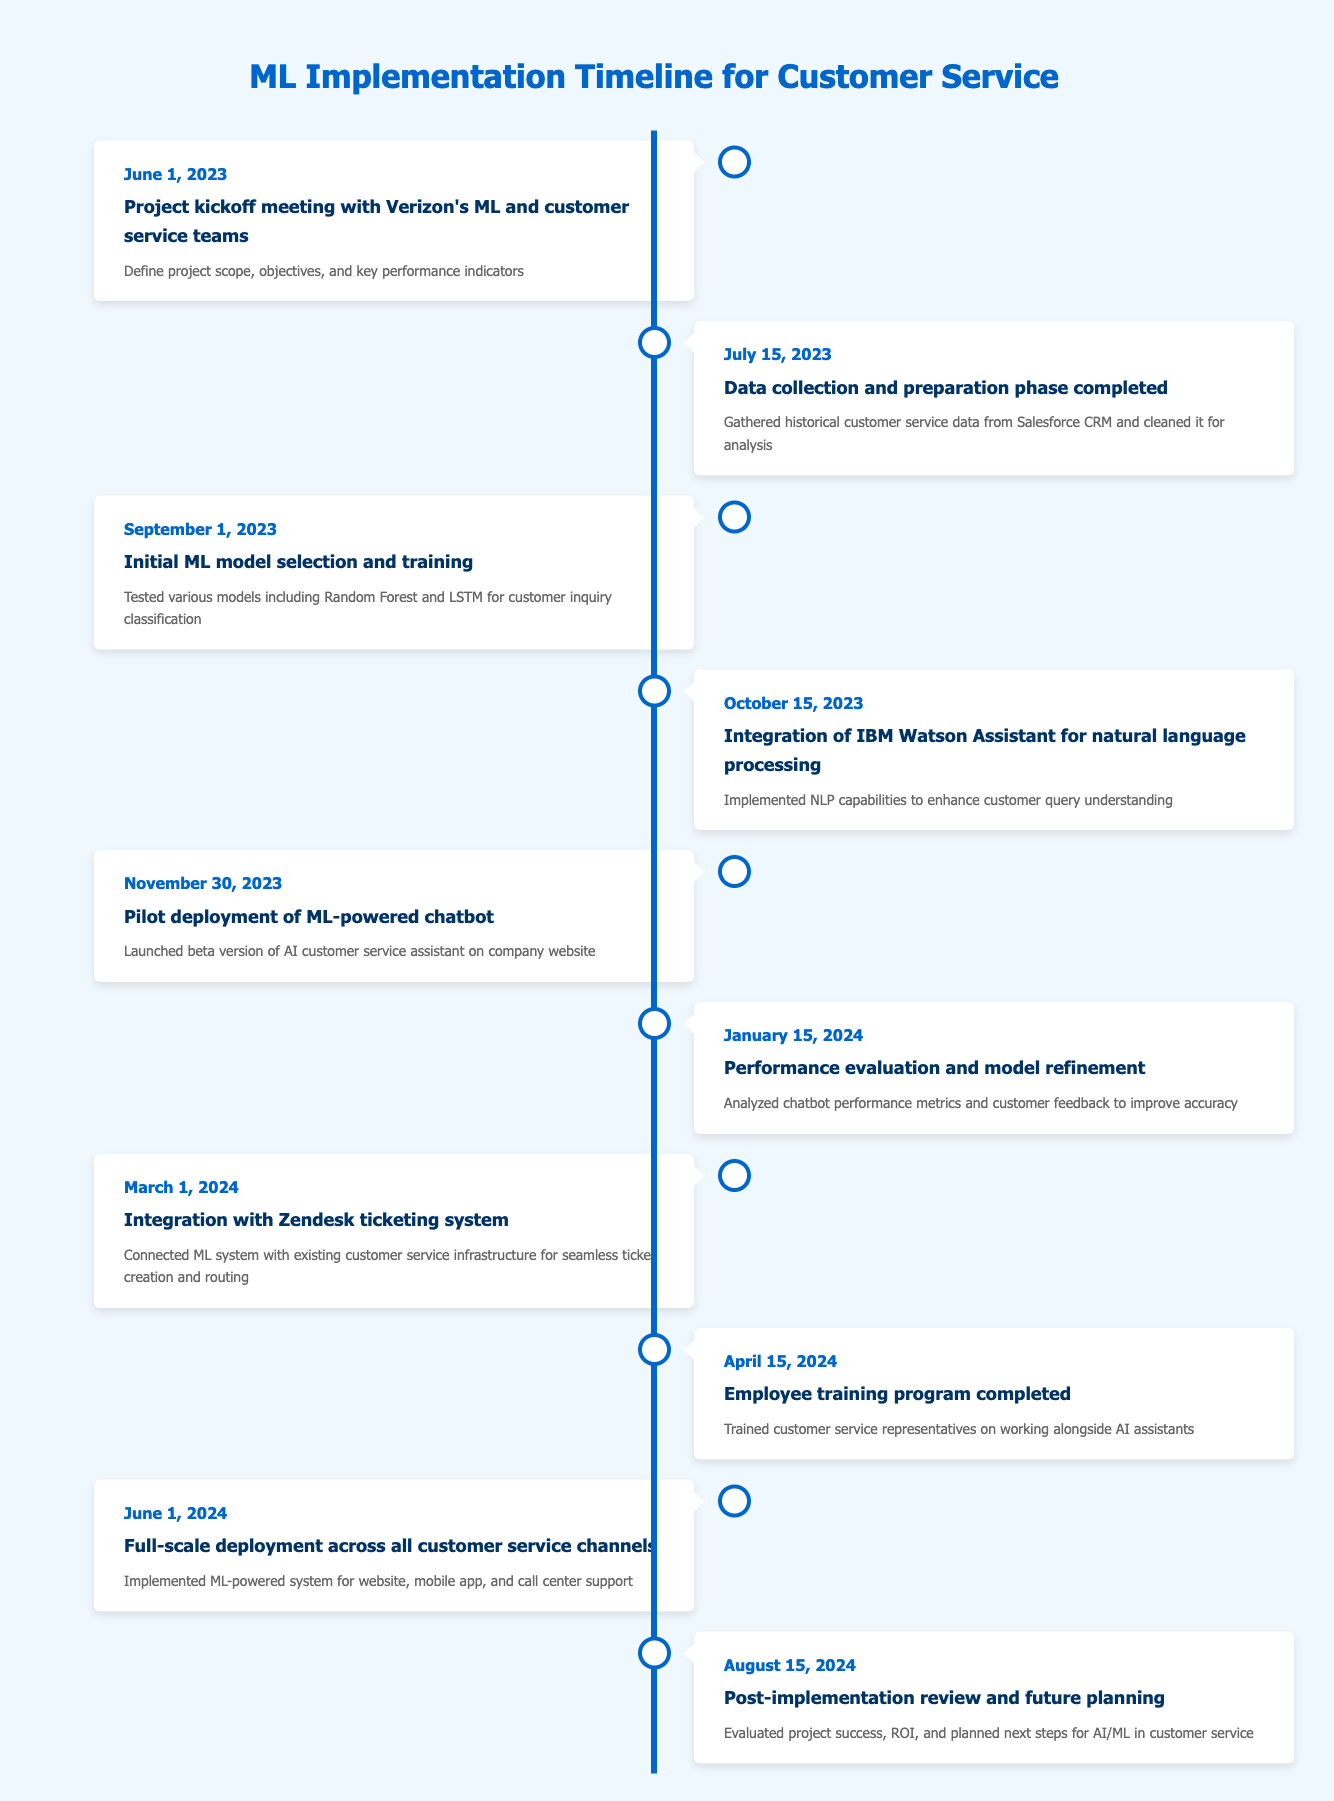What was the first milestone in the implementation timeline? The first milestone is listed under June 1, 2023, where a project kickoff meeting with Verizon's ML and customer service teams took place.
Answer: Project kickoff meeting with Verizon's ML and customer service teams What date did the data collection and preparation phase complete? The data collection and preparation phase completed on July 15, 2023, as indicated in the timeline.
Answer: July 15, 2023 Was the ML-powered chatbot launched before the integration of IBM Watson Assistant? The timeline shows that the integration of IBM Watson Assistant occurred on October 15, 2023, and the chatbot was launched on November 30, 2023. Therefore, yes, the chatbot was launched after the integration of IBM Watson Assistant.
Answer: Yes How many months were there between the pilot deployment of the ML-powered chatbot and the full-scale deployment? The pilot deployment of the chatbot took place on November 30, 2023, and the full-scale deployment occurred on June 1, 2024. Counting these months: December, January, February, March, April, May totals 6 months.
Answer: 6 months What was the last milestone achieved according to the timeline? The last milestone listed in the timeline is the post-implementation review and future planning, which occurred on August 15, 2024.
Answer: Post-implementation review and future planning What changes occurred in the timeline from the initial model selection to the performance evaluation? The initial ML model selection and training happened on September 1, 2023, and the performance evaluation and model refinement occurred on January 15, 2024. This shows a gap of over 4 months where the models were trained and evaluated using performance metrics and customer feedback for improvement.
Answer: Over 4 months of training and evaluation How many distinct integrations with other systems are mentioned in the timeline? There are two distinct integrations mentioned: one with IBM Watson Assistant for natural language processing and another with Zendesk ticketing system.
Answer: 2 integrations What was the purpose of the employee training program completed on April 15, 2024? The purpose of the employee training program was to train customer service representatives on working alongside AI assistants, as specified in the milestone description.
Answer: To train representatives on working with AI assistants 